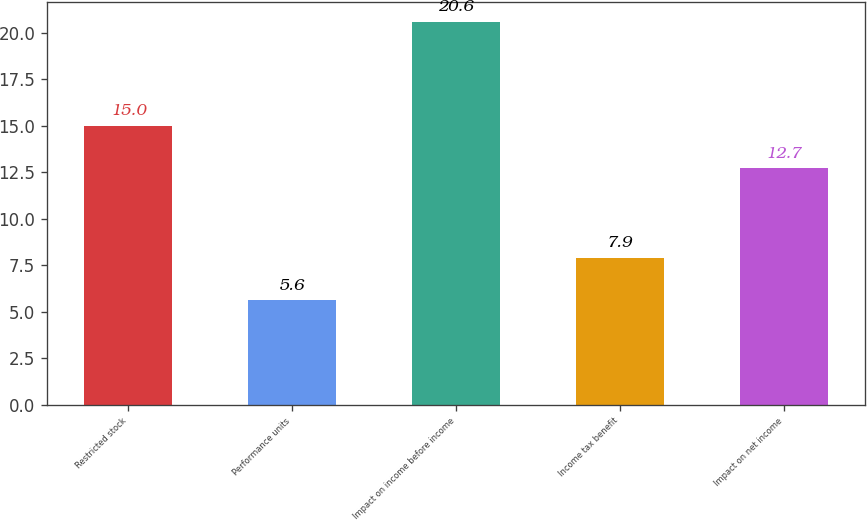<chart> <loc_0><loc_0><loc_500><loc_500><bar_chart><fcel>Restricted stock<fcel>Performance units<fcel>Impact on income before income<fcel>Income tax benefit<fcel>Impact on net income<nl><fcel>15<fcel>5.6<fcel>20.6<fcel>7.9<fcel>12.7<nl></chart> 